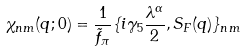Convert formula to latex. <formula><loc_0><loc_0><loc_500><loc_500>\chi _ { n m } ( q ; 0 ) = \frac { 1 } { \tilde { f } _ { \pi } } \{ i \gamma _ { 5 } \frac { \lambda ^ { \alpha } } { 2 } , S _ { F } ( q ) \} _ { n m }</formula> 